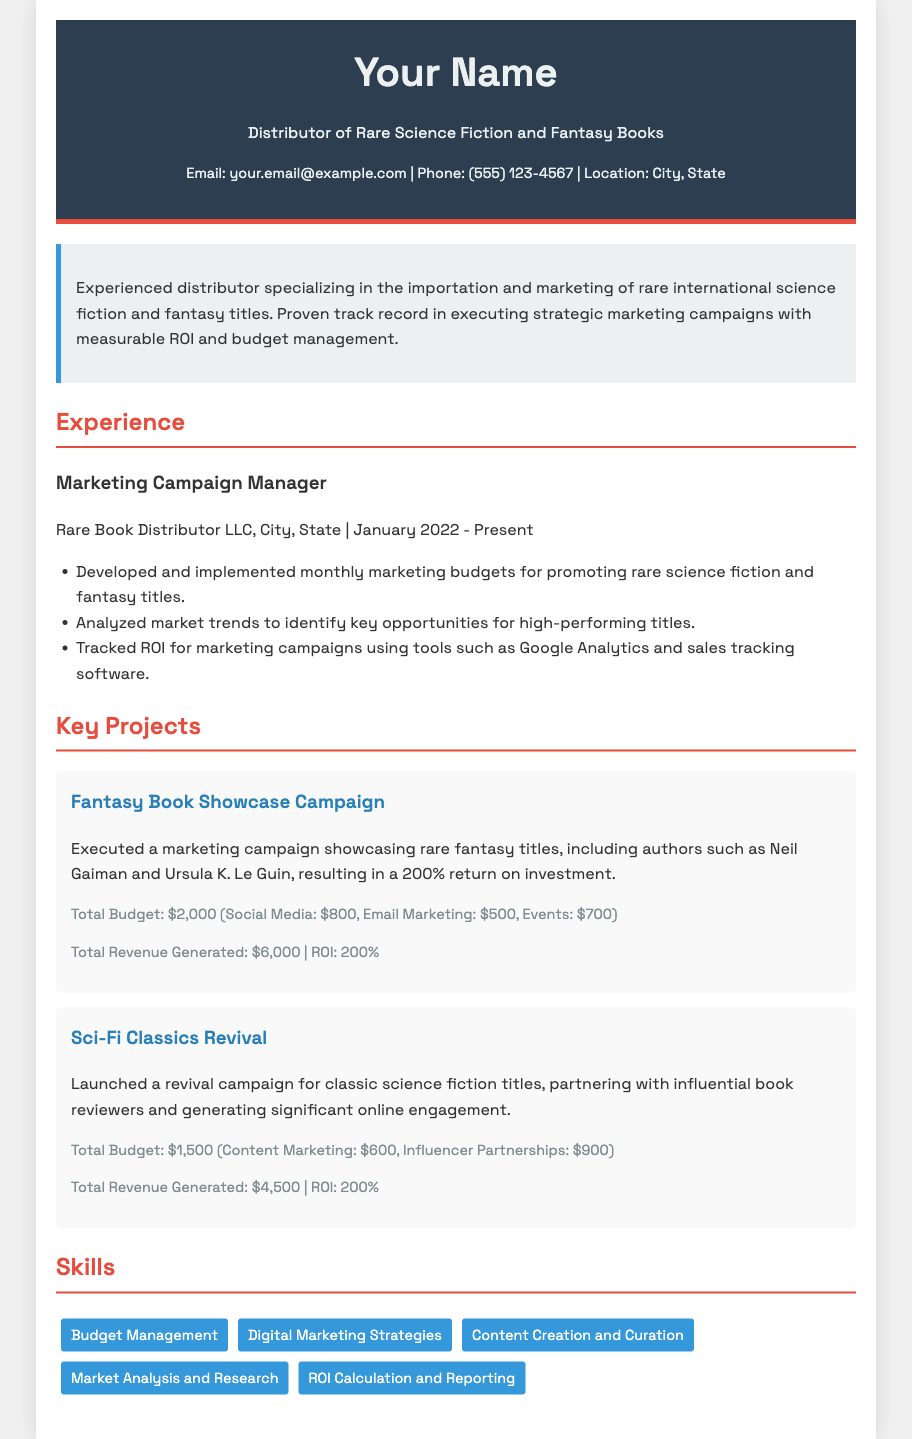What is your current job title? The current job title is listed in the experience section of the document, which is Marketing Campaign Manager.
Answer: Marketing Campaign Manager What is the total budget for the Fantasy Book Showcase Campaign? The budget for the Fantasy Book Showcase Campaign is specified in the budget section for that project, which amounts to $2,000.
Answer: $2,000 What is the ROI for the Sci-Fi Classics Revival campaign? The ROI for the Sci-Fi Classics Revival campaign is stated in the ROI section for that project, which is 200%.
Answer: 200% Which two authors were highlighted in the Fantasy Book Showcase Campaign? The document mentions Neil Gaiman and Ursula K. Le Guin as the authors highlighted in that campaign.
Answer: Neil Gaiman and Ursula K. Le Guin How many key projects are outlined in the document? The number of key projects can be counted from the projects section, which lists two key projects.
Answer: 2 What percentage return on investment is reported in both campaigns? Both campaigns report a return on investment of 200%, as indicated in their respective ROI details.
Answer: 200% What month and year did the Marketing Campaign Manager start working? The month and year of starting the job is indicated in the experience section, which is January 2022.
Answer: January 2022 What marketing tool is mentioned for tracking ROI in campaigns? The specific tool mentioned for tracking ROI is Google Analytics.
Answer: Google Analytics 